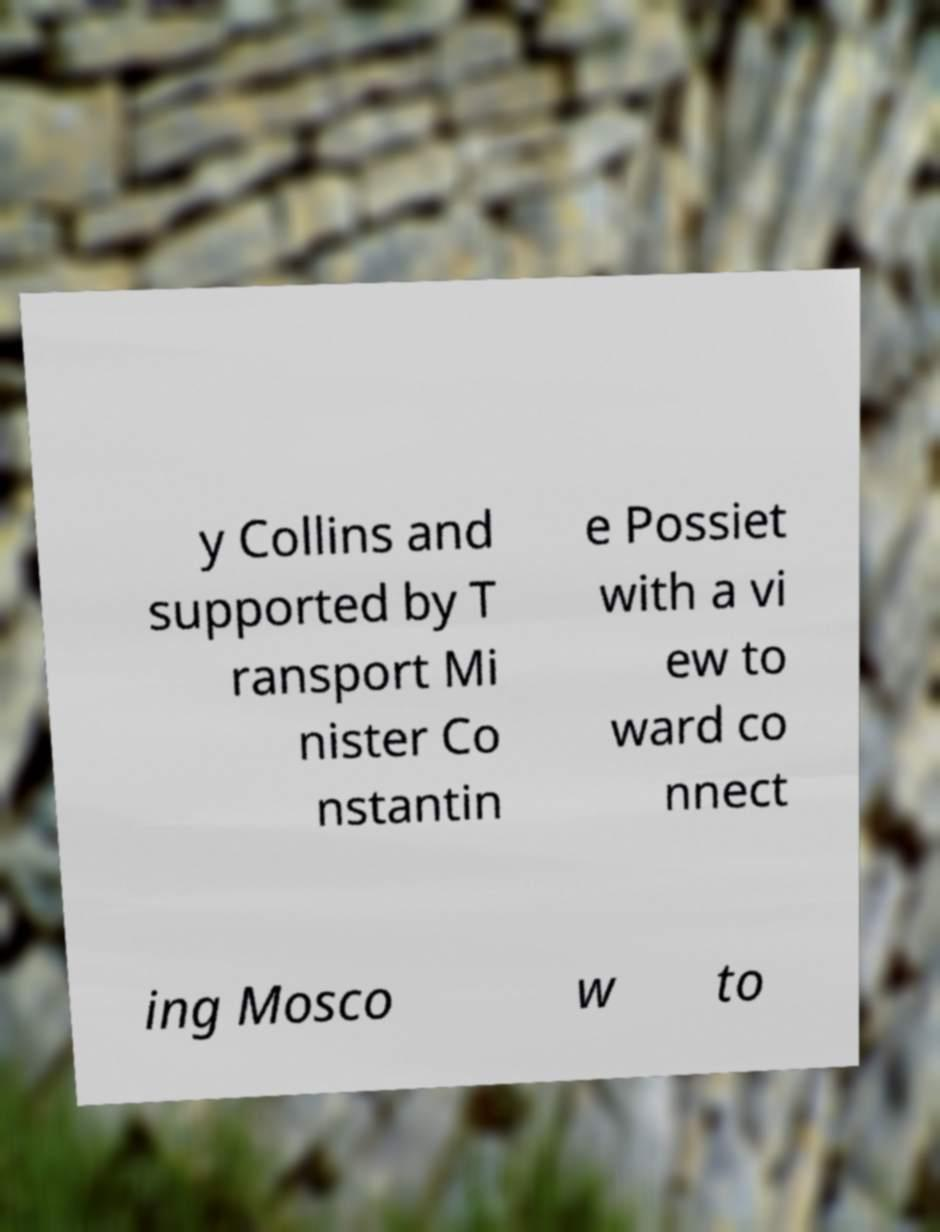For documentation purposes, I need the text within this image transcribed. Could you provide that? y Collins and supported by T ransport Mi nister Co nstantin e Possiet with a vi ew to ward co nnect ing Mosco w to 